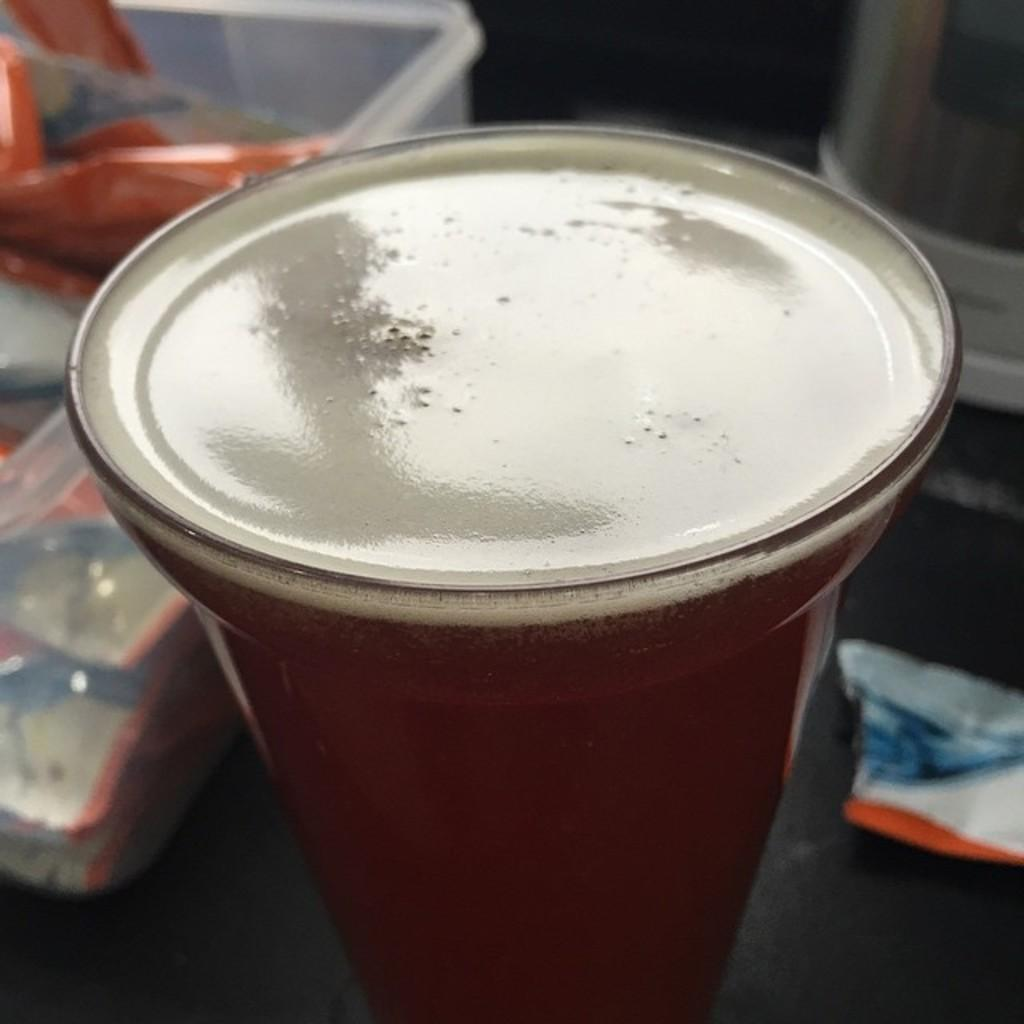What object is present in the image that can hold liquid? There is a glass in the image that can hold liquid. What is inside the glass? There is liquid visible in the glass. What can be seen in the background of the image? There is a box in the background of the image. What type of gold can be seen in the pocket of the person in the image? There is no person or gold present in the image. How many grains of rice are visible in the image? There is no rice or grains present in the image. 